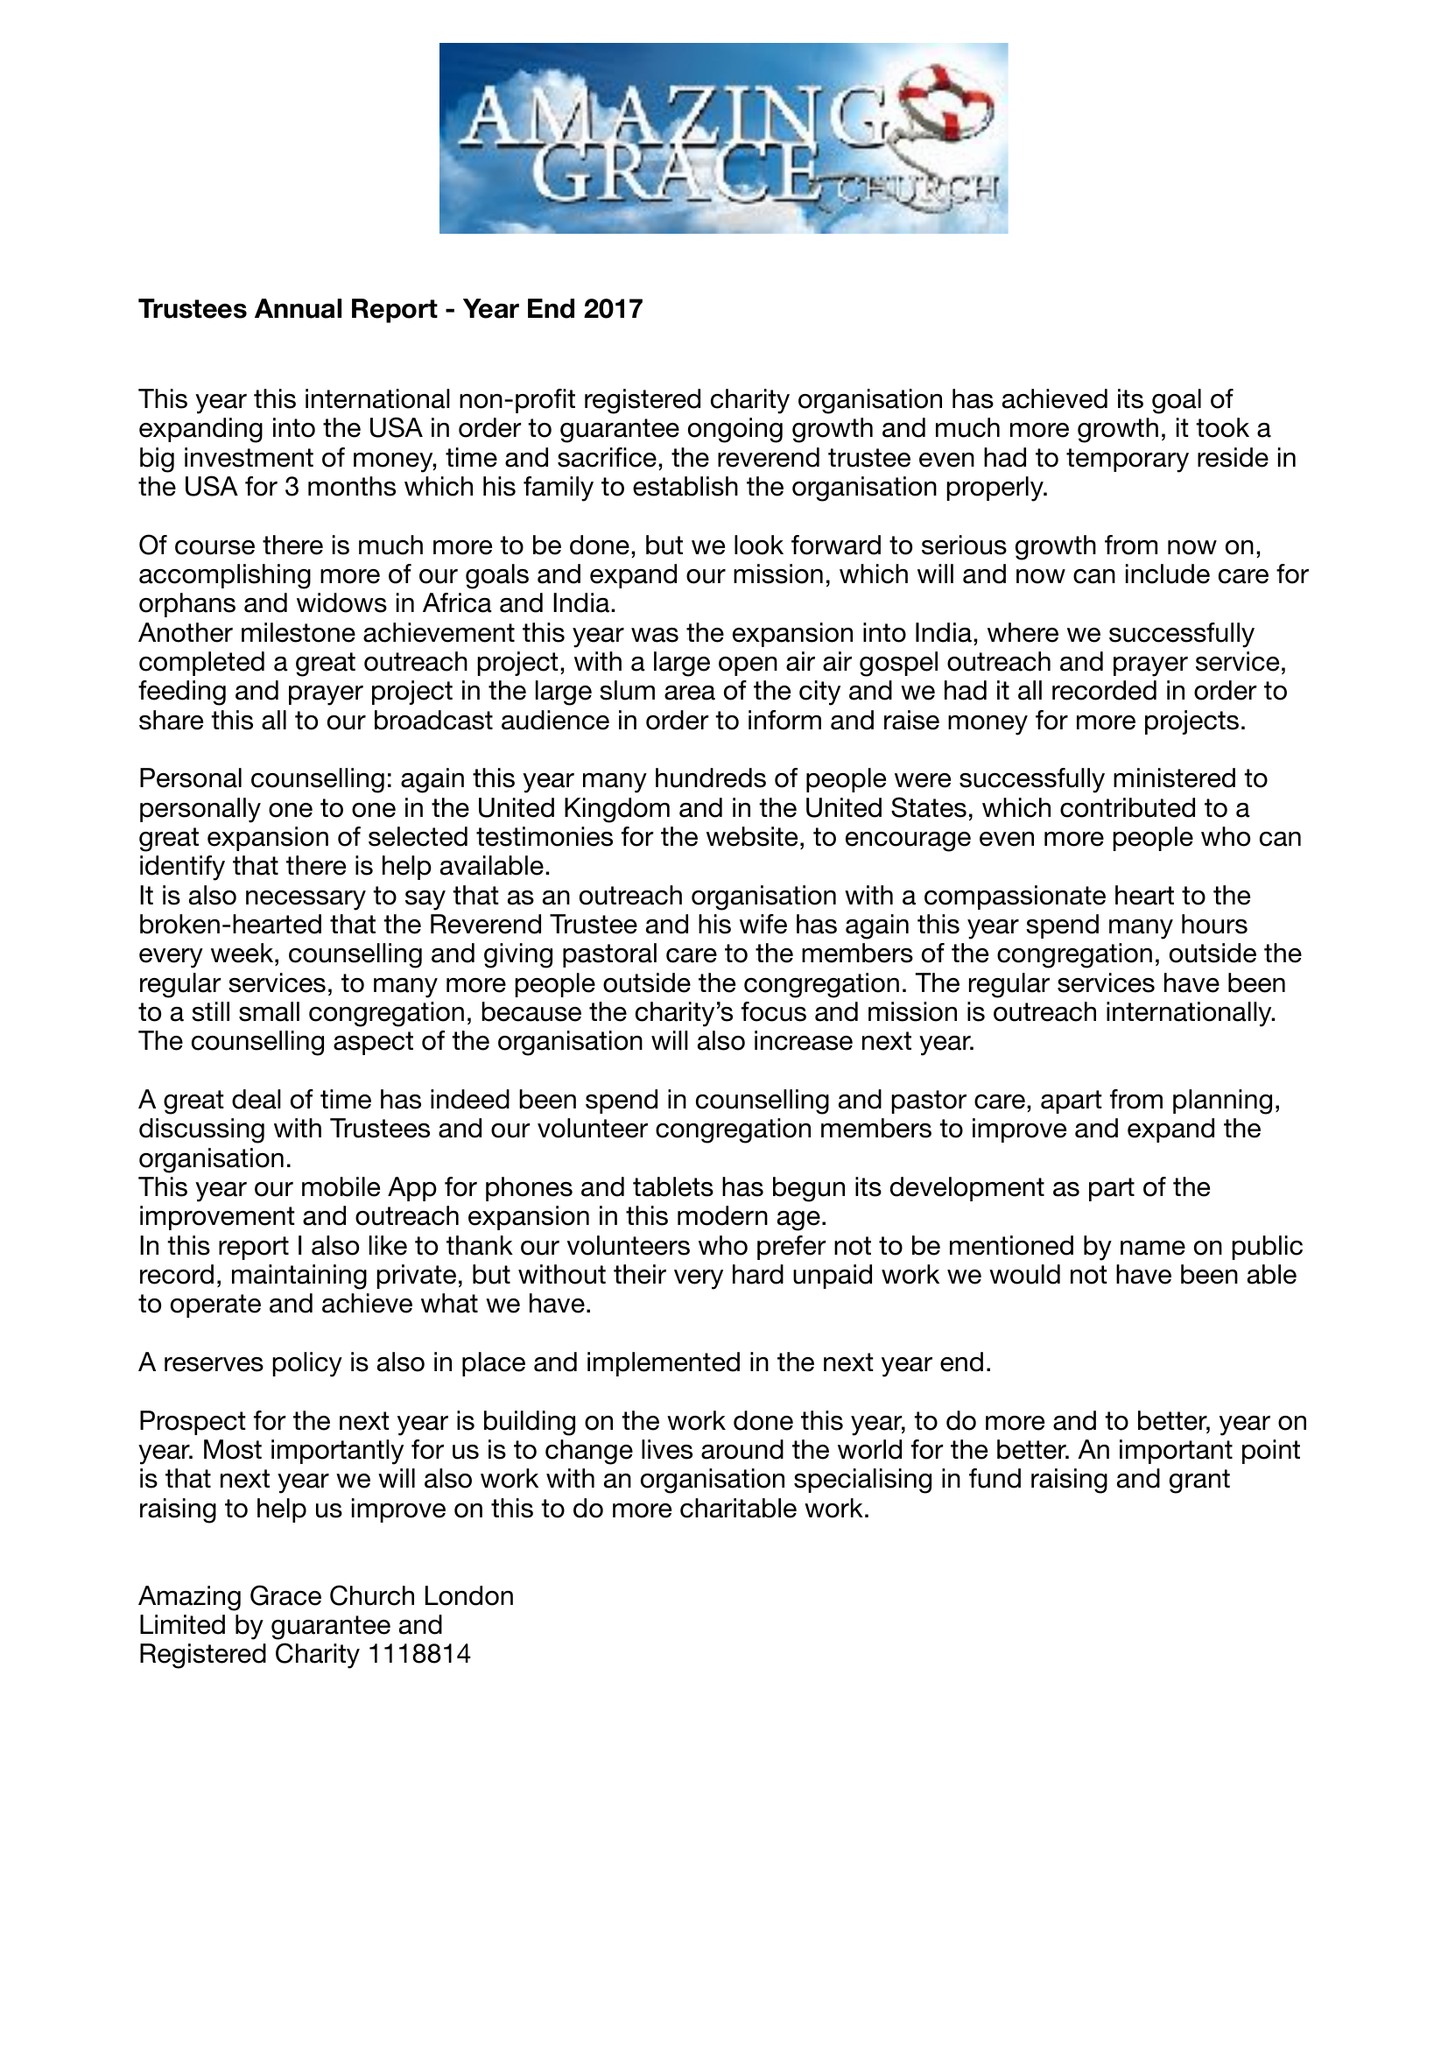What is the value for the address__post_town?
Answer the question using a single word or phrase. LONDON 